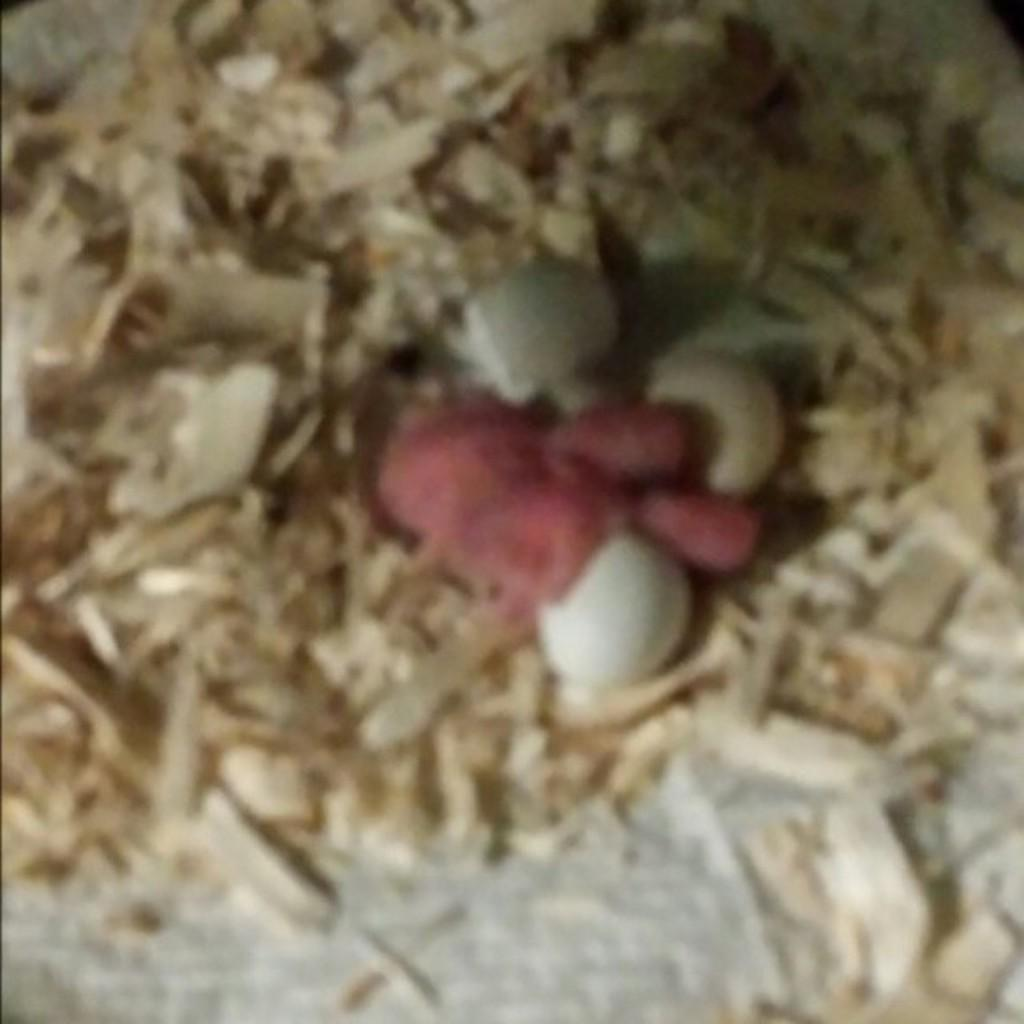What type of waste is visible in the image? There is wood waste in the image. What type of plant is growing in the wood waste in the image? There is no plant visible in the image; it only shows wood waste. 